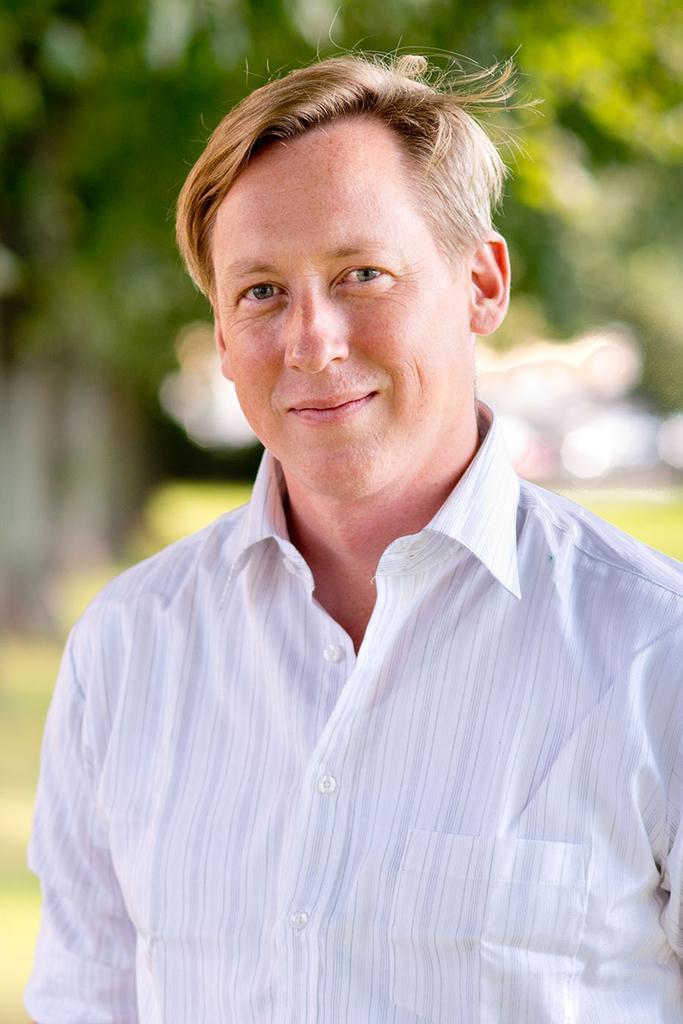Can you describe this image briefly? In this image there is a man smiling, and there is blur background. 